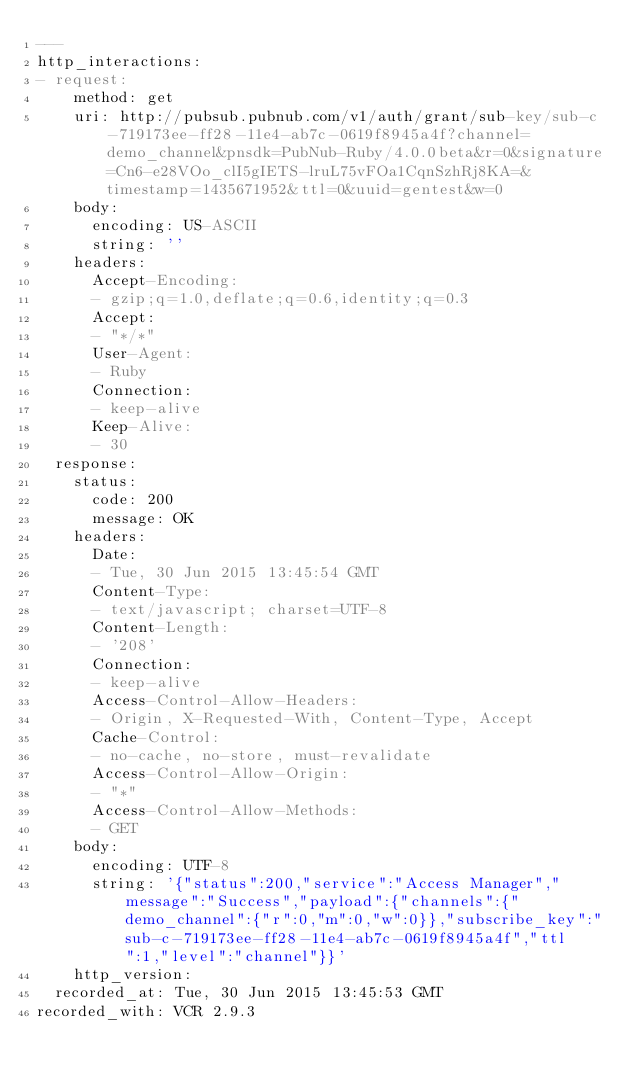Convert code to text. <code><loc_0><loc_0><loc_500><loc_500><_YAML_>---
http_interactions:
- request:
    method: get
    uri: http://pubsub.pubnub.com/v1/auth/grant/sub-key/sub-c-719173ee-ff28-11e4-ab7c-0619f8945a4f?channel=demo_channel&pnsdk=PubNub-Ruby/4.0.0beta&r=0&signature=Cn6-e28VOo_clI5gIETS-lruL75vFOa1CqnSzhRj8KA=&timestamp=1435671952&ttl=0&uuid=gentest&w=0
    body:
      encoding: US-ASCII
      string: ''
    headers:
      Accept-Encoding:
      - gzip;q=1.0,deflate;q=0.6,identity;q=0.3
      Accept:
      - "*/*"
      User-Agent:
      - Ruby
      Connection:
      - keep-alive
      Keep-Alive:
      - 30
  response:
    status:
      code: 200
      message: OK
    headers:
      Date:
      - Tue, 30 Jun 2015 13:45:54 GMT
      Content-Type:
      - text/javascript; charset=UTF-8
      Content-Length:
      - '208'
      Connection:
      - keep-alive
      Access-Control-Allow-Headers:
      - Origin, X-Requested-With, Content-Type, Accept
      Cache-Control:
      - no-cache, no-store, must-revalidate
      Access-Control-Allow-Origin:
      - "*"
      Access-Control-Allow-Methods:
      - GET
    body:
      encoding: UTF-8
      string: '{"status":200,"service":"Access Manager","message":"Success","payload":{"channels":{"demo_channel":{"r":0,"m":0,"w":0}},"subscribe_key":"sub-c-719173ee-ff28-11e4-ab7c-0619f8945a4f","ttl":1,"level":"channel"}}'
    http_version: 
  recorded_at: Tue, 30 Jun 2015 13:45:53 GMT
recorded_with: VCR 2.9.3
</code> 